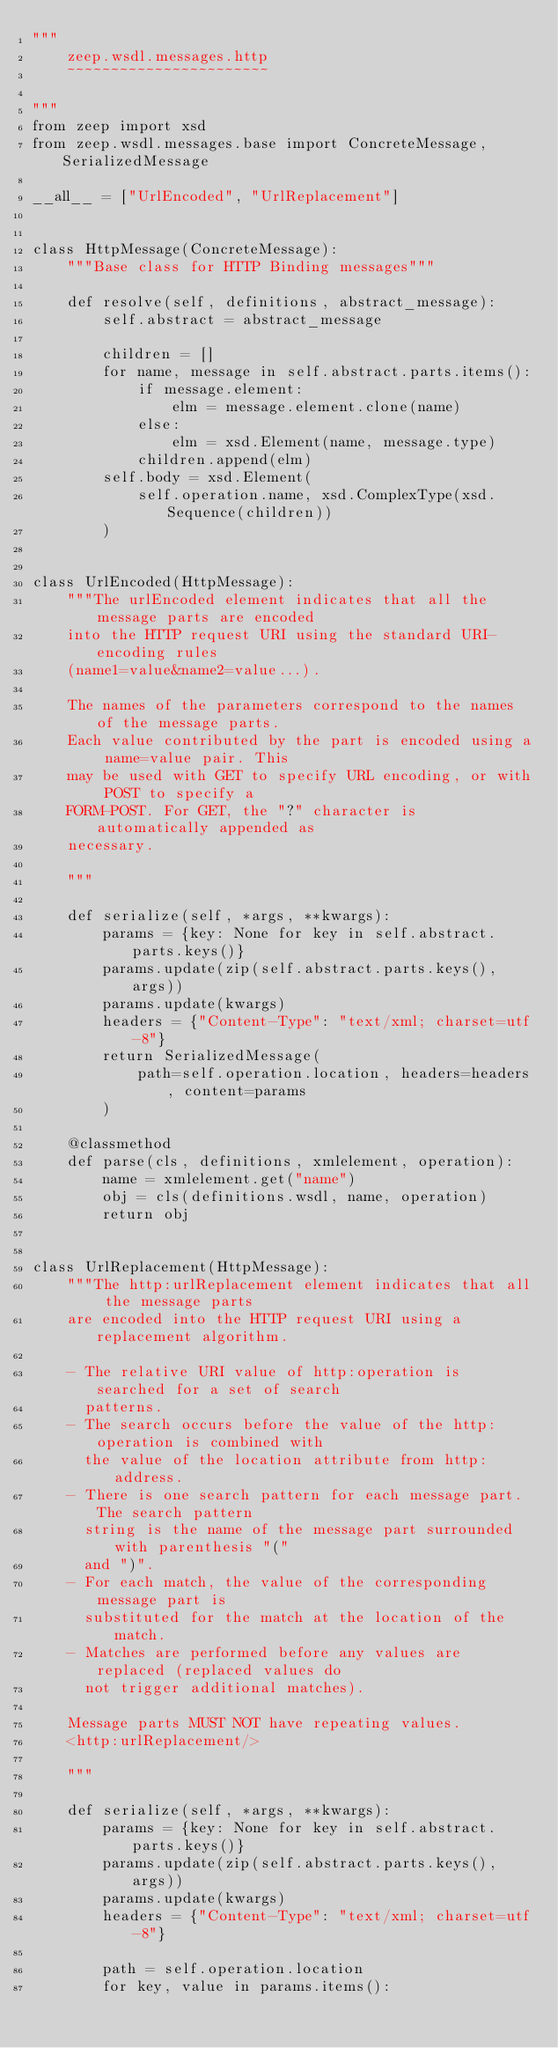<code> <loc_0><loc_0><loc_500><loc_500><_Python_>"""
    zeep.wsdl.messages.http
    ~~~~~~~~~~~~~~~~~~~~~~~

"""
from zeep import xsd
from zeep.wsdl.messages.base import ConcreteMessage, SerializedMessage

__all__ = ["UrlEncoded", "UrlReplacement"]


class HttpMessage(ConcreteMessage):
    """Base class for HTTP Binding messages"""

    def resolve(self, definitions, abstract_message):
        self.abstract = abstract_message

        children = []
        for name, message in self.abstract.parts.items():
            if message.element:
                elm = message.element.clone(name)
            else:
                elm = xsd.Element(name, message.type)
            children.append(elm)
        self.body = xsd.Element(
            self.operation.name, xsd.ComplexType(xsd.Sequence(children))
        )


class UrlEncoded(HttpMessage):
    """The urlEncoded element indicates that all the message parts are encoded
    into the HTTP request URI using the standard URI-encoding rules
    (name1=value&name2=value...).

    The names of the parameters correspond to the names of the message parts.
    Each value contributed by the part is encoded using a name=value pair. This
    may be used with GET to specify URL encoding, or with POST to specify a
    FORM-POST. For GET, the "?" character is automatically appended as
    necessary.

    """

    def serialize(self, *args, **kwargs):
        params = {key: None for key in self.abstract.parts.keys()}
        params.update(zip(self.abstract.parts.keys(), args))
        params.update(kwargs)
        headers = {"Content-Type": "text/xml; charset=utf-8"}
        return SerializedMessage(
            path=self.operation.location, headers=headers, content=params
        )

    @classmethod
    def parse(cls, definitions, xmlelement, operation):
        name = xmlelement.get("name")
        obj = cls(definitions.wsdl, name, operation)
        return obj


class UrlReplacement(HttpMessage):
    """The http:urlReplacement element indicates that all the message parts
    are encoded into the HTTP request URI using a replacement algorithm.

    - The relative URI value of http:operation is searched for a set of search
      patterns.
    - The search occurs before the value of the http:operation is combined with
      the value of the location attribute from http:address.
    - There is one search pattern for each message part. The search pattern
      string is the name of the message part surrounded with parenthesis "("
      and ")".
    - For each match, the value of the corresponding message part is
      substituted for the match at the location of the match.
    - Matches are performed before any values are replaced (replaced values do
      not trigger additional matches).

    Message parts MUST NOT have repeating values.
    <http:urlReplacement/>

    """

    def serialize(self, *args, **kwargs):
        params = {key: None for key in self.abstract.parts.keys()}
        params.update(zip(self.abstract.parts.keys(), args))
        params.update(kwargs)
        headers = {"Content-Type": "text/xml; charset=utf-8"}

        path = self.operation.location
        for key, value in params.items():</code> 